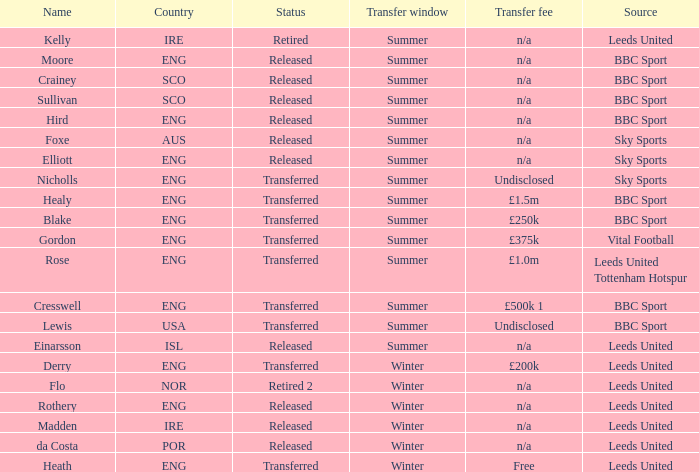What is the present situation of the individual called nicholls? Transferred. 